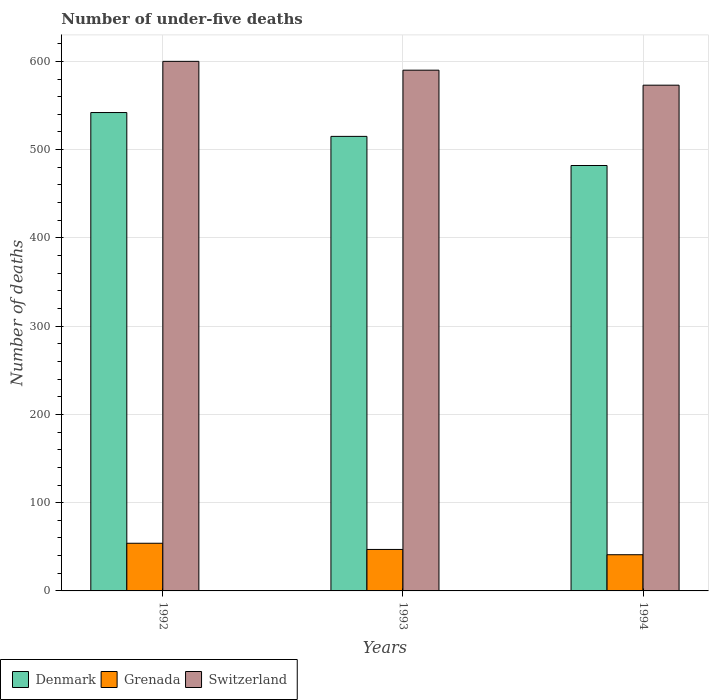How many bars are there on the 3rd tick from the left?
Offer a terse response. 3. What is the number of under-five deaths in Grenada in 1993?
Give a very brief answer. 47. Across all years, what is the maximum number of under-five deaths in Switzerland?
Your response must be concise. 600. Across all years, what is the minimum number of under-five deaths in Denmark?
Offer a terse response. 482. In which year was the number of under-five deaths in Denmark maximum?
Your answer should be compact. 1992. In which year was the number of under-five deaths in Switzerland minimum?
Your response must be concise. 1994. What is the total number of under-five deaths in Switzerland in the graph?
Keep it short and to the point. 1763. What is the difference between the number of under-five deaths in Switzerland in 1992 and that in 1993?
Provide a succinct answer. 10. What is the difference between the number of under-five deaths in Denmark in 1992 and the number of under-five deaths in Switzerland in 1993?
Make the answer very short. -48. What is the average number of under-five deaths in Denmark per year?
Your answer should be very brief. 513. In the year 1992, what is the difference between the number of under-five deaths in Denmark and number of under-five deaths in Switzerland?
Ensure brevity in your answer.  -58. In how many years, is the number of under-five deaths in Denmark greater than 300?
Your response must be concise. 3. What is the ratio of the number of under-five deaths in Denmark in 1992 to that in 1994?
Provide a short and direct response. 1.12. Is the number of under-five deaths in Switzerland in 1992 less than that in 1993?
Keep it short and to the point. No. What is the difference between the highest and the second highest number of under-five deaths in Denmark?
Provide a short and direct response. 27. What is the difference between the highest and the lowest number of under-five deaths in Grenada?
Provide a short and direct response. 13. What does the 3rd bar from the left in 1994 represents?
Offer a very short reply. Switzerland. What does the 2nd bar from the right in 1992 represents?
Ensure brevity in your answer.  Grenada. Are all the bars in the graph horizontal?
Make the answer very short. No. Are the values on the major ticks of Y-axis written in scientific E-notation?
Offer a very short reply. No. Where does the legend appear in the graph?
Your response must be concise. Bottom left. How many legend labels are there?
Offer a terse response. 3. How are the legend labels stacked?
Provide a succinct answer. Horizontal. What is the title of the graph?
Make the answer very short. Number of under-five deaths. What is the label or title of the Y-axis?
Offer a terse response. Number of deaths. What is the Number of deaths in Denmark in 1992?
Your answer should be very brief. 542. What is the Number of deaths in Grenada in 1992?
Your answer should be compact. 54. What is the Number of deaths in Switzerland in 1992?
Your answer should be very brief. 600. What is the Number of deaths of Denmark in 1993?
Offer a terse response. 515. What is the Number of deaths in Switzerland in 1993?
Your answer should be very brief. 590. What is the Number of deaths of Denmark in 1994?
Ensure brevity in your answer.  482. What is the Number of deaths in Grenada in 1994?
Your response must be concise. 41. What is the Number of deaths in Switzerland in 1994?
Your response must be concise. 573. Across all years, what is the maximum Number of deaths of Denmark?
Provide a succinct answer. 542. Across all years, what is the maximum Number of deaths of Grenada?
Provide a succinct answer. 54. Across all years, what is the maximum Number of deaths in Switzerland?
Offer a very short reply. 600. Across all years, what is the minimum Number of deaths in Denmark?
Provide a short and direct response. 482. Across all years, what is the minimum Number of deaths of Switzerland?
Your response must be concise. 573. What is the total Number of deaths of Denmark in the graph?
Keep it short and to the point. 1539. What is the total Number of deaths in Grenada in the graph?
Offer a terse response. 142. What is the total Number of deaths of Switzerland in the graph?
Offer a terse response. 1763. What is the difference between the Number of deaths of Denmark in 1992 and that in 1993?
Your response must be concise. 27. What is the difference between the Number of deaths in Switzerland in 1992 and that in 1993?
Your answer should be very brief. 10. What is the difference between the Number of deaths of Grenada in 1992 and that in 1994?
Your response must be concise. 13. What is the difference between the Number of deaths of Denmark in 1993 and that in 1994?
Provide a succinct answer. 33. What is the difference between the Number of deaths of Grenada in 1993 and that in 1994?
Make the answer very short. 6. What is the difference between the Number of deaths of Switzerland in 1993 and that in 1994?
Provide a short and direct response. 17. What is the difference between the Number of deaths of Denmark in 1992 and the Number of deaths of Grenada in 1993?
Your answer should be very brief. 495. What is the difference between the Number of deaths of Denmark in 1992 and the Number of deaths of Switzerland in 1993?
Provide a short and direct response. -48. What is the difference between the Number of deaths of Grenada in 1992 and the Number of deaths of Switzerland in 1993?
Your answer should be compact. -536. What is the difference between the Number of deaths of Denmark in 1992 and the Number of deaths of Grenada in 1994?
Keep it short and to the point. 501. What is the difference between the Number of deaths in Denmark in 1992 and the Number of deaths in Switzerland in 1994?
Ensure brevity in your answer.  -31. What is the difference between the Number of deaths of Grenada in 1992 and the Number of deaths of Switzerland in 1994?
Offer a very short reply. -519. What is the difference between the Number of deaths in Denmark in 1993 and the Number of deaths in Grenada in 1994?
Provide a succinct answer. 474. What is the difference between the Number of deaths in Denmark in 1993 and the Number of deaths in Switzerland in 1994?
Give a very brief answer. -58. What is the difference between the Number of deaths in Grenada in 1993 and the Number of deaths in Switzerland in 1994?
Keep it short and to the point. -526. What is the average Number of deaths in Denmark per year?
Your answer should be very brief. 513. What is the average Number of deaths of Grenada per year?
Provide a short and direct response. 47.33. What is the average Number of deaths of Switzerland per year?
Ensure brevity in your answer.  587.67. In the year 1992, what is the difference between the Number of deaths in Denmark and Number of deaths in Grenada?
Offer a terse response. 488. In the year 1992, what is the difference between the Number of deaths of Denmark and Number of deaths of Switzerland?
Your answer should be very brief. -58. In the year 1992, what is the difference between the Number of deaths of Grenada and Number of deaths of Switzerland?
Ensure brevity in your answer.  -546. In the year 1993, what is the difference between the Number of deaths in Denmark and Number of deaths in Grenada?
Offer a very short reply. 468. In the year 1993, what is the difference between the Number of deaths of Denmark and Number of deaths of Switzerland?
Keep it short and to the point. -75. In the year 1993, what is the difference between the Number of deaths of Grenada and Number of deaths of Switzerland?
Your answer should be compact. -543. In the year 1994, what is the difference between the Number of deaths of Denmark and Number of deaths of Grenada?
Your answer should be very brief. 441. In the year 1994, what is the difference between the Number of deaths of Denmark and Number of deaths of Switzerland?
Make the answer very short. -91. In the year 1994, what is the difference between the Number of deaths in Grenada and Number of deaths in Switzerland?
Provide a short and direct response. -532. What is the ratio of the Number of deaths of Denmark in 1992 to that in 1993?
Provide a succinct answer. 1.05. What is the ratio of the Number of deaths of Grenada in 1992 to that in 1993?
Provide a short and direct response. 1.15. What is the ratio of the Number of deaths of Switzerland in 1992 to that in 1993?
Provide a short and direct response. 1.02. What is the ratio of the Number of deaths of Denmark in 1992 to that in 1994?
Make the answer very short. 1.12. What is the ratio of the Number of deaths in Grenada in 1992 to that in 1994?
Your response must be concise. 1.32. What is the ratio of the Number of deaths in Switzerland in 1992 to that in 1994?
Offer a very short reply. 1.05. What is the ratio of the Number of deaths in Denmark in 1993 to that in 1994?
Make the answer very short. 1.07. What is the ratio of the Number of deaths of Grenada in 1993 to that in 1994?
Ensure brevity in your answer.  1.15. What is the ratio of the Number of deaths of Switzerland in 1993 to that in 1994?
Keep it short and to the point. 1.03. What is the difference between the highest and the second highest Number of deaths of Denmark?
Make the answer very short. 27. What is the difference between the highest and the lowest Number of deaths in Switzerland?
Make the answer very short. 27. 